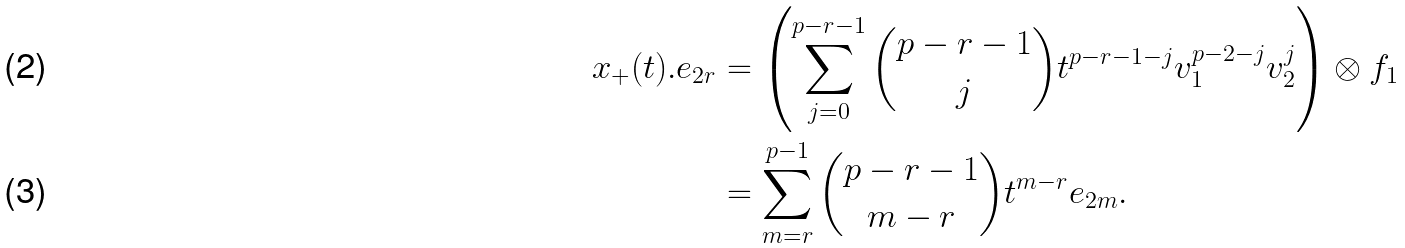<formula> <loc_0><loc_0><loc_500><loc_500>x _ { + } ( t ) . e _ { 2 r } & = \left ( \sum _ { j = 0 } ^ { p - r - 1 } \binom { p - r - 1 } { j } t ^ { p - r - 1 - j } v _ { 1 } ^ { p - 2 - j } v _ { 2 } ^ { j } \right ) \otimes f _ { 1 } \\ & = \sum _ { m = r } ^ { p - 1 } \binom { p - r - 1 } { m - r } t ^ { m - r } e _ { 2 m } .</formula> 